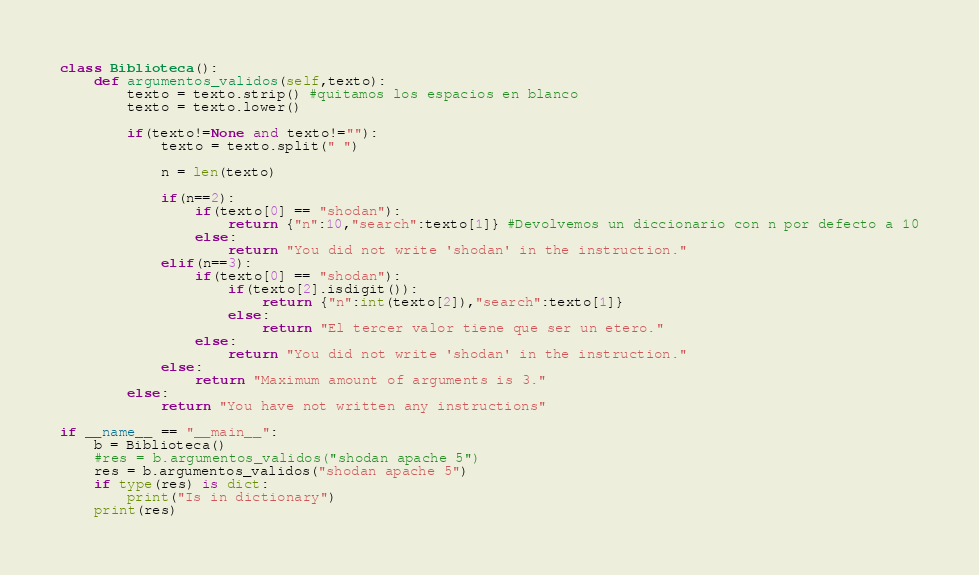<code> <loc_0><loc_0><loc_500><loc_500><_Python_>class Biblioteca():
    def argumentos_validos(self,texto):
        texto = texto.strip() #quitamos los espacios en blanco
        texto = texto.lower()

        if(texto!=None and texto!=""):
            texto = texto.split(" ")

            n = len(texto)

            if(n==2):
                if(texto[0] == "shodan"):
                    return {"n":10,"search":texto[1]} #Devolvemos un diccionario con n por defecto a 10
                else:
                    return "You did not write 'shodan' in the instruction."
            elif(n==3):
                if(texto[0] == "shodan"):
                    if(texto[2].isdigit()):
                        return {"n":int(texto[2]),"search":texto[1]}
                    else:
                        return "El tercer valor tiene que ser un etero."
                else:
                    return "You did not write 'shodan' in the instruction."
            else:
                return "Maximum amount of arguments is 3."
        else:
            return "You have not written any instructions"

if __name__ == "__main__":
    b = Biblioteca()
    #res = b.argumentos_validos("shodan apache 5")
    res = b.argumentos_validos("shodan apache 5")
    if type(res) is dict:
        print("Is in dictionary")
    print(res)
</code> 